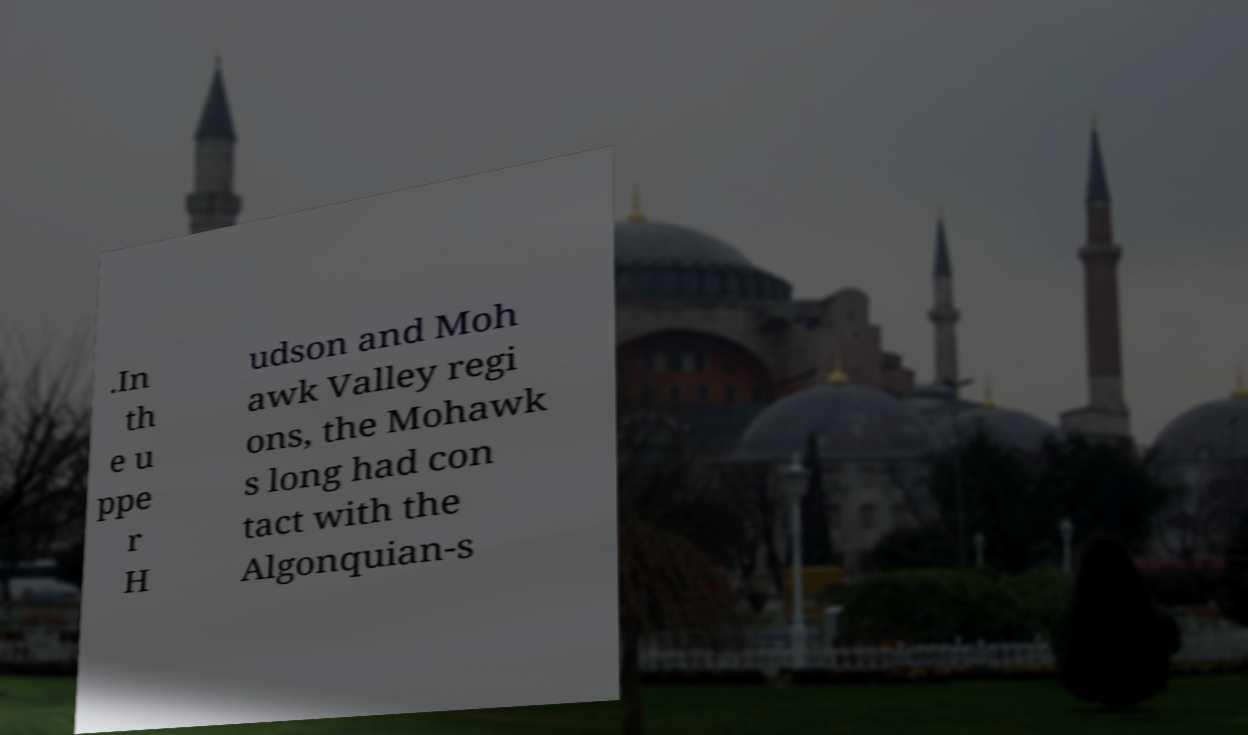For documentation purposes, I need the text within this image transcribed. Could you provide that? .In th e u ppe r H udson and Moh awk Valley regi ons, the Mohawk s long had con tact with the Algonquian-s 